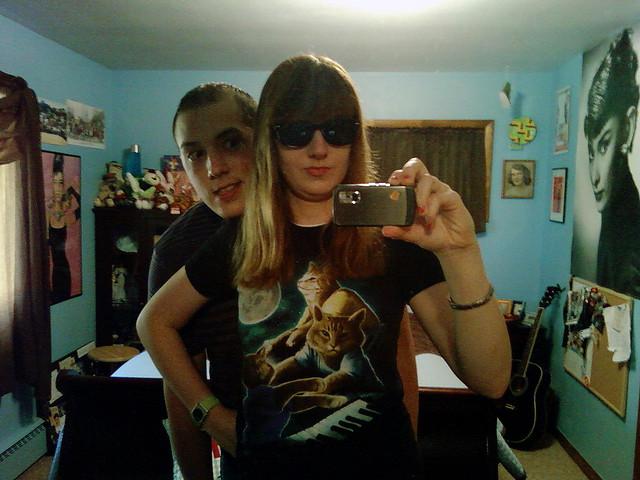How many people are in the room?
Answer briefly. 2. Why is the girl wearing sunglasses?
Short answer required. Bright. What is the girl holding?
Keep it brief. Camera. Is this girl standing with her grandfather?
Concise answer only. No. How many pairs of sunglasses are there?
Write a very short answer. 1. How many people are in the picture?
Be succinct. 2. What does the woman have over her shoulders?
Be succinct. Man. How many people are recording or taking pictures of the man?
Concise answer only. 1. What color is the woman wearing?
Give a very brief answer. Black. What hairstyle does the closest woman have?
Give a very brief answer. Long. Why is the man with the camera crouching?
Quick response, please. To be in picture. What the people doing?
Keep it brief. Taking picture. What is the woman holding?
Short answer required. Phone. Is this couple married?
Keep it brief. No. Who is wearing a wrist watch?
Concise answer only. Girl. What is the girl going?
Be succinct. Taking selfie. What rock band is on the black shirt?
Give a very brief answer. None. 